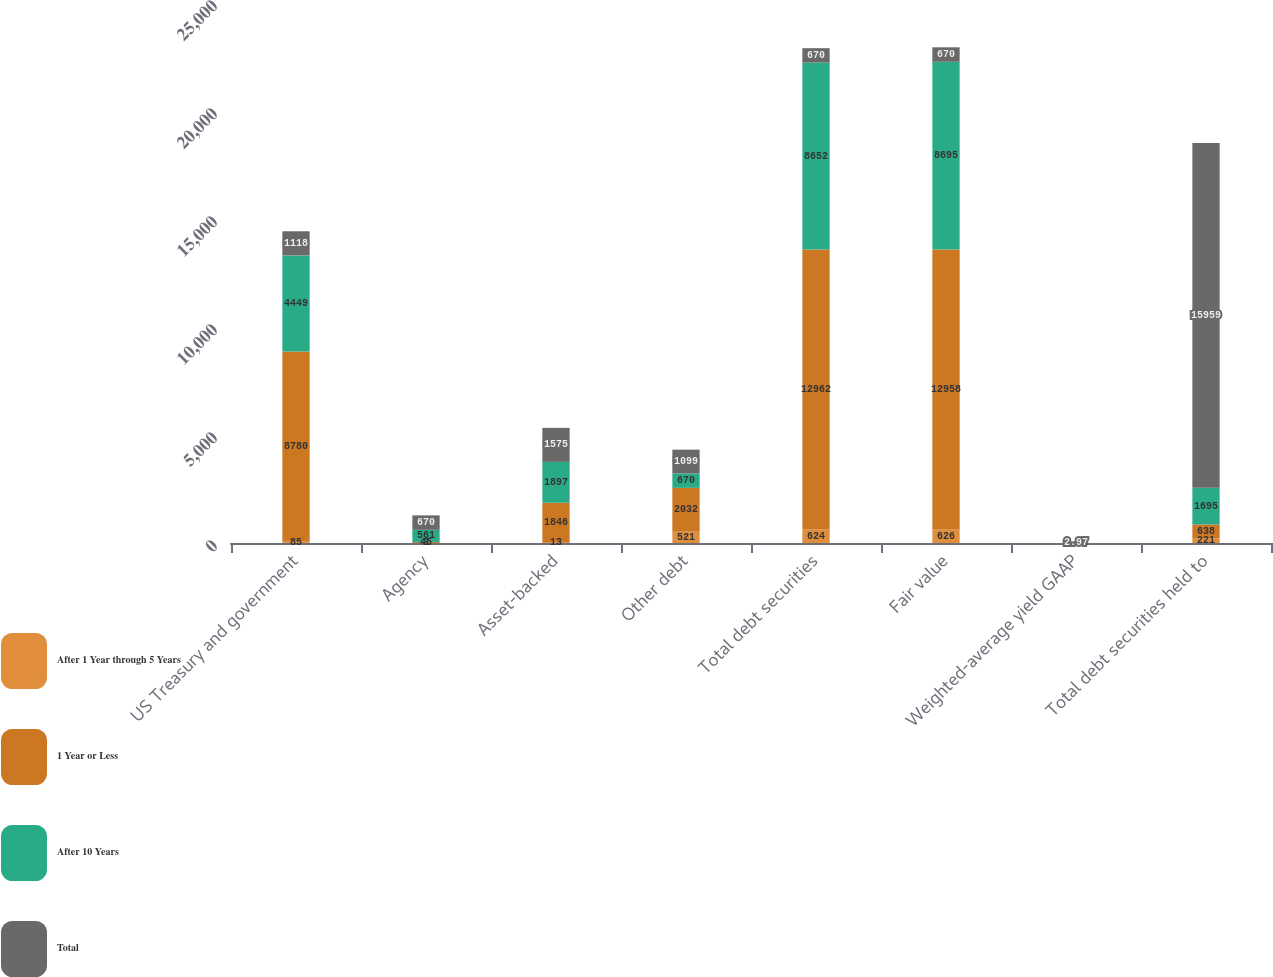<chart> <loc_0><loc_0><loc_500><loc_500><stacked_bar_chart><ecel><fcel>US Treasury and government<fcel>Agency<fcel>Asset-backed<fcel>Other debt<fcel>Total debt securities<fcel>Fair value<fcel>Weighted-average yield GAAP<fcel>Total debt securities held to<nl><fcel>After 1 Year through 5 Years<fcel>85<fcel>3<fcel>13<fcel>521<fcel>624<fcel>626<fcel>2.73<fcel>221<nl><fcel>1 Year or Less<fcel>8780<fcel>45<fcel>1846<fcel>2032<fcel>12962<fcel>12958<fcel>2.12<fcel>638<nl><fcel>After 10 Years<fcel>4449<fcel>561<fcel>1897<fcel>670<fcel>8652<fcel>8695<fcel>2.29<fcel>1695<nl><fcel>Total<fcel>1118<fcel>670<fcel>1575<fcel>1099<fcel>670<fcel>670<fcel>2.97<fcel>15959<nl></chart> 